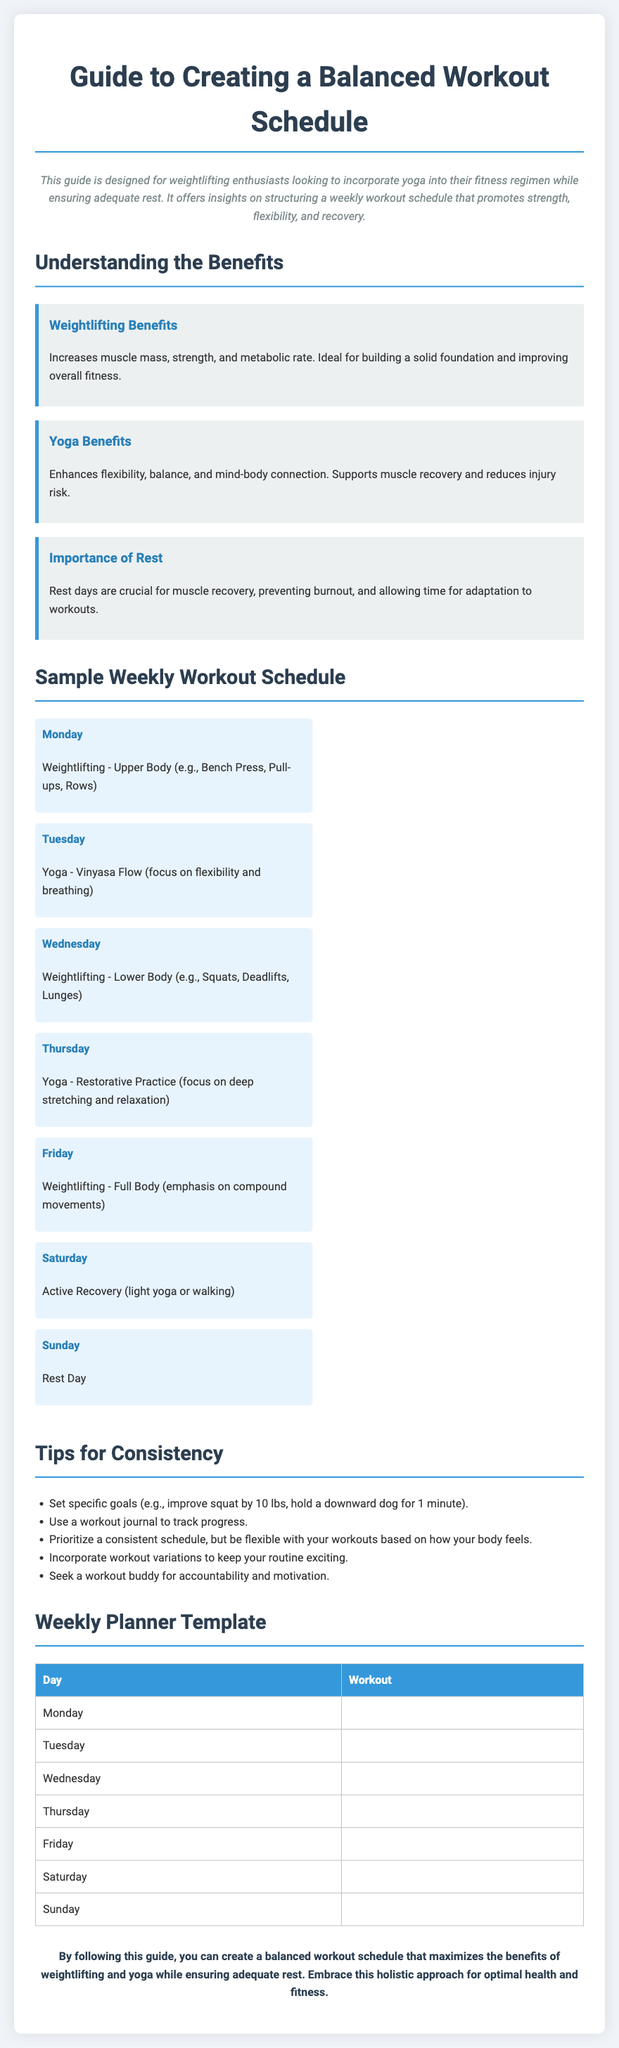What is the title of the guide? The title of the guide is stated at the top of the document.
Answer: Guide to Creating a Balanced Workout Schedule What workout does Monday focus on? The specific workout for Monday is detailed in the Sample Weekly Workout Schedule section.
Answer: Weightlifting - Upper Body What are the benefits of yoga? The benefits of yoga are outlined in the Understanding the Benefits section.
Answer: Enhances flexibility, balance, and mind-body connection How many rest days are included in the weekly schedule? The number of rest days is identified in the Sample Weekly Workout Schedule.
Answer: One (1) What is one tip for consistency mentioned? A tip for consistency is provided in the Tips for Consistency section.
Answer: Set specific goals What is the primary focus of Thursday's workout? The focus of Thursday’s workout is described in the Sample Weekly Workout Schedule.
Answer: Yoga - Restorative Practice How many types of workouts are mentioned overall in the guide? The types of workouts are explained throughout the document.
Answer: Three (3) What is emphasized in the conclusion of the guide? The conclusion summarizes the essential takeaway of the guide.
Answer: Balanced workout schedule 